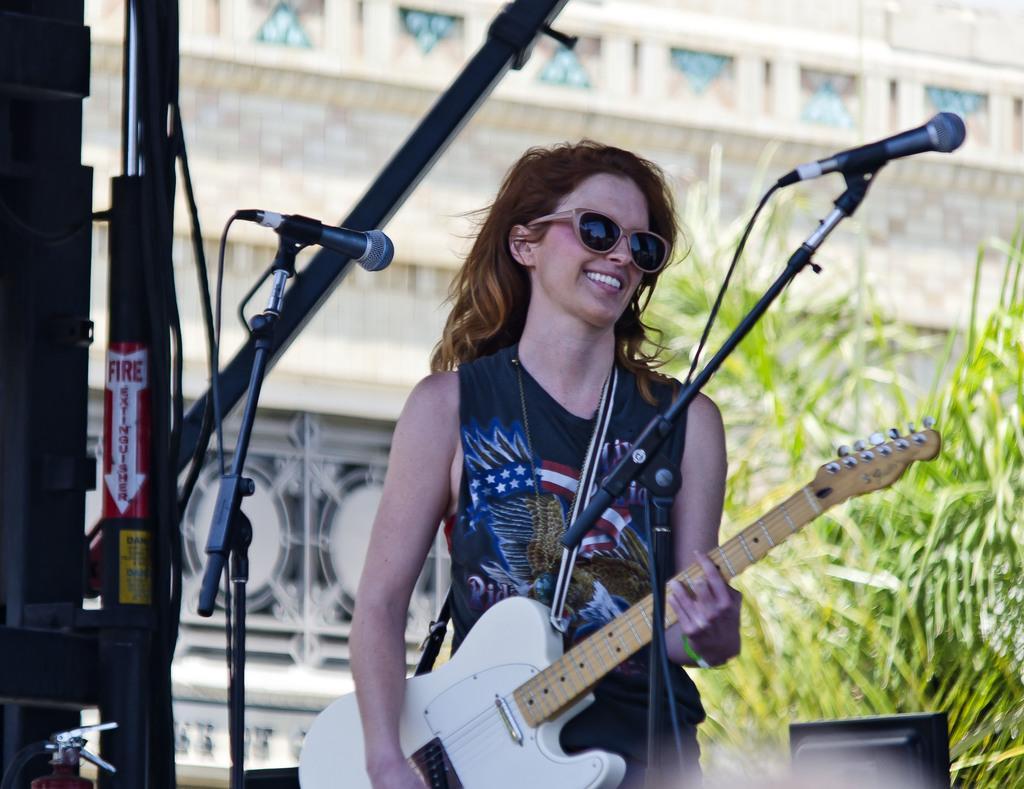Please provide a concise description of this image. In this picture we can see a woman is standing and smiling and holding a guitar in her hands, and in front here is the microphone and stand, and at back here is the tree, and here is the building. 